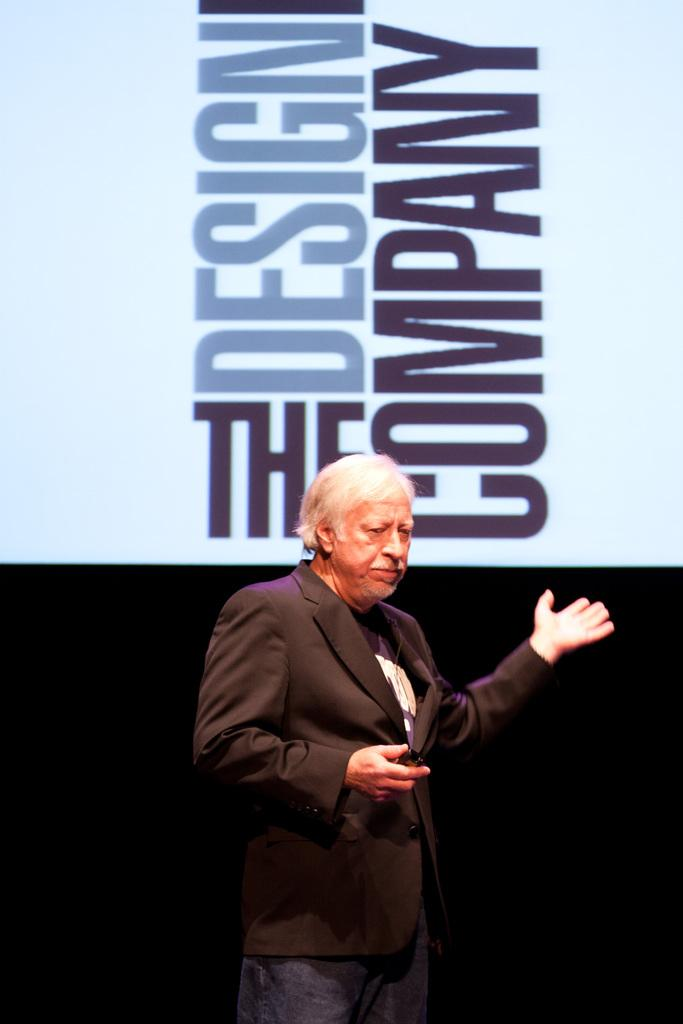<image>
Relay a brief, clear account of the picture shown. An older man is giving a presentation for The Design Company. 